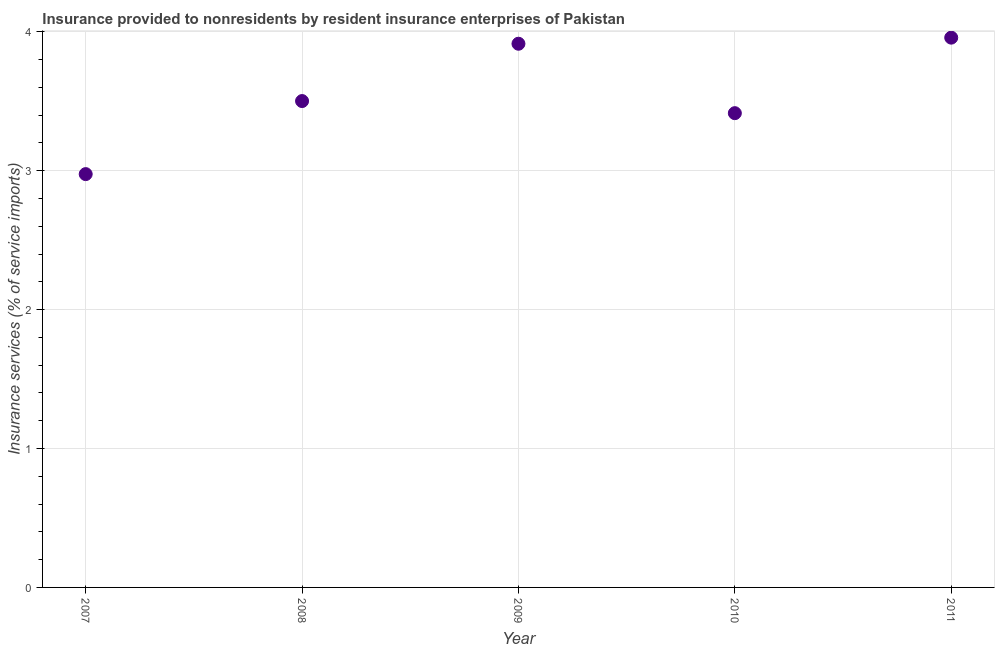What is the insurance and financial services in 2010?
Your answer should be compact. 3.41. Across all years, what is the maximum insurance and financial services?
Ensure brevity in your answer.  3.96. Across all years, what is the minimum insurance and financial services?
Keep it short and to the point. 2.98. In which year was the insurance and financial services maximum?
Your answer should be compact. 2011. What is the sum of the insurance and financial services?
Provide a succinct answer. 17.77. What is the difference between the insurance and financial services in 2007 and 2011?
Keep it short and to the point. -0.98. What is the average insurance and financial services per year?
Make the answer very short. 3.55. What is the median insurance and financial services?
Your answer should be compact. 3.5. What is the ratio of the insurance and financial services in 2007 to that in 2011?
Keep it short and to the point. 0.75. What is the difference between the highest and the second highest insurance and financial services?
Provide a succinct answer. 0.04. Is the sum of the insurance and financial services in 2007 and 2009 greater than the maximum insurance and financial services across all years?
Your answer should be compact. Yes. What is the difference between the highest and the lowest insurance and financial services?
Your response must be concise. 0.98. How many years are there in the graph?
Give a very brief answer. 5. What is the difference between two consecutive major ticks on the Y-axis?
Your answer should be very brief. 1. Does the graph contain any zero values?
Keep it short and to the point. No. Does the graph contain grids?
Provide a succinct answer. Yes. What is the title of the graph?
Offer a very short reply. Insurance provided to nonresidents by resident insurance enterprises of Pakistan. What is the label or title of the X-axis?
Provide a succinct answer. Year. What is the label or title of the Y-axis?
Keep it short and to the point. Insurance services (% of service imports). What is the Insurance services (% of service imports) in 2007?
Offer a very short reply. 2.98. What is the Insurance services (% of service imports) in 2008?
Offer a terse response. 3.5. What is the Insurance services (% of service imports) in 2009?
Ensure brevity in your answer.  3.91. What is the Insurance services (% of service imports) in 2010?
Provide a short and direct response. 3.41. What is the Insurance services (% of service imports) in 2011?
Provide a short and direct response. 3.96. What is the difference between the Insurance services (% of service imports) in 2007 and 2008?
Offer a terse response. -0.53. What is the difference between the Insurance services (% of service imports) in 2007 and 2009?
Keep it short and to the point. -0.94. What is the difference between the Insurance services (% of service imports) in 2007 and 2010?
Keep it short and to the point. -0.44. What is the difference between the Insurance services (% of service imports) in 2007 and 2011?
Offer a very short reply. -0.98. What is the difference between the Insurance services (% of service imports) in 2008 and 2009?
Keep it short and to the point. -0.41. What is the difference between the Insurance services (% of service imports) in 2008 and 2010?
Give a very brief answer. 0.09. What is the difference between the Insurance services (% of service imports) in 2008 and 2011?
Ensure brevity in your answer.  -0.46. What is the difference between the Insurance services (% of service imports) in 2009 and 2010?
Your answer should be compact. 0.5. What is the difference between the Insurance services (% of service imports) in 2009 and 2011?
Ensure brevity in your answer.  -0.04. What is the difference between the Insurance services (% of service imports) in 2010 and 2011?
Your answer should be very brief. -0.54. What is the ratio of the Insurance services (% of service imports) in 2007 to that in 2009?
Provide a succinct answer. 0.76. What is the ratio of the Insurance services (% of service imports) in 2007 to that in 2010?
Give a very brief answer. 0.87. What is the ratio of the Insurance services (% of service imports) in 2007 to that in 2011?
Your answer should be compact. 0.75. What is the ratio of the Insurance services (% of service imports) in 2008 to that in 2009?
Provide a succinct answer. 0.9. What is the ratio of the Insurance services (% of service imports) in 2008 to that in 2010?
Keep it short and to the point. 1.03. What is the ratio of the Insurance services (% of service imports) in 2008 to that in 2011?
Ensure brevity in your answer.  0.89. What is the ratio of the Insurance services (% of service imports) in 2009 to that in 2010?
Provide a succinct answer. 1.15. What is the ratio of the Insurance services (% of service imports) in 2009 to that in 2011?
Keep it short and to the point. 0.99. What is the ratio of the Insurance services (% of service imports) in 2010 to that in 2011?
Your response must be concise. 0.86. 